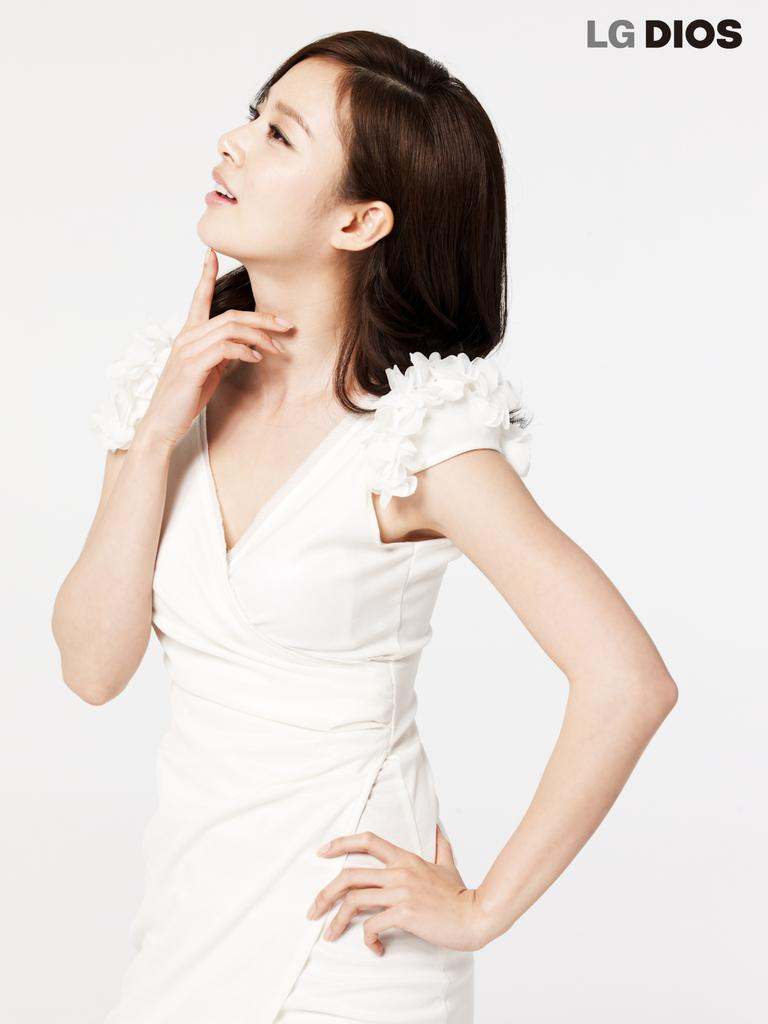Who is the main subject in the image? There is a woman in the image. What is the woman doing in the image? The woman is standing. What is the woman wearing in the image? The woman is wearing a white dress. What can be seen in the background of the image? The background of the image is white. What type of body of water is visible in the image? There is no body of water present in the image. 